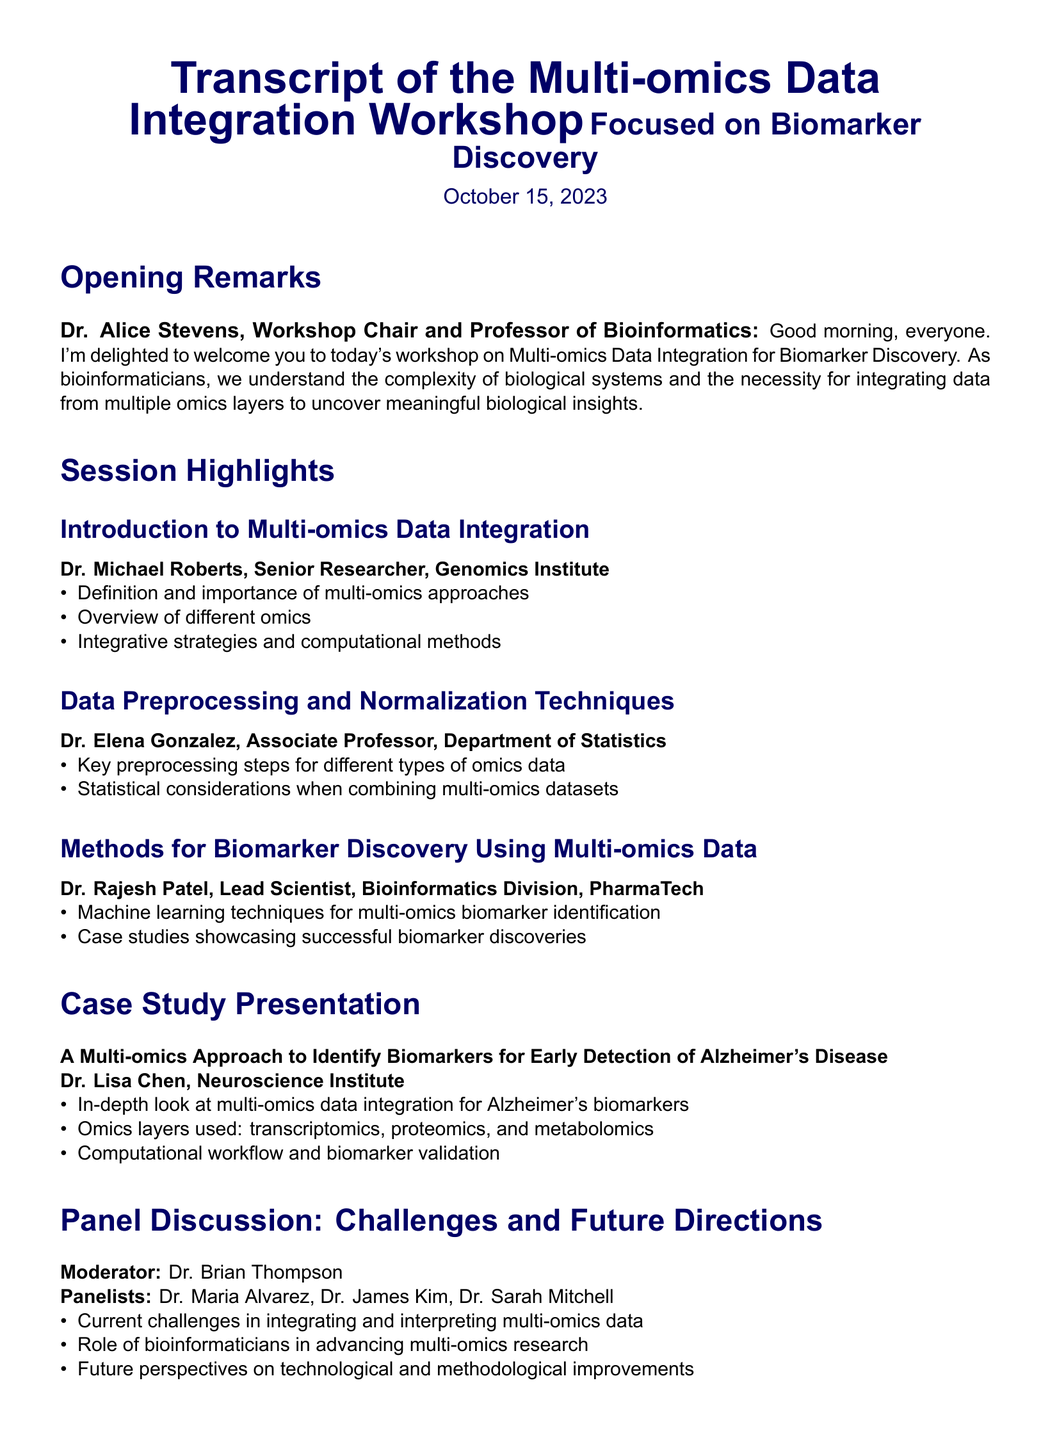What is the date of the workshop? The date of the workshop is mentioned clearly at the top of the document.
Answer: October 15, 2023 Who is the workshop chair? The workshop chair is stated in the opening remarks section.
Answer: Dr. Alice Stevens Which omics layers are used in the Alzheimer's disease case study? The omics layers are listed in the case study section under Dr. Lisa Chen's presentation.
Answer: transcriptomics, proteomics, and metabolomics What is one key topic discussed by Dr. Elena Gonzalez? Dr. Elena Gonzalez discusses key preprocessing steps, which is mentioned in her section.
Answer: Preprocessing steps What role do bioinformaticians play in multi-omics research? The panel discussion addresses the role of bioinformaticians.
Answer: Advancing research What is a method highlighted by Dr. Rajesh Patel for biomarker identification? The methods discussed by Dr. Rajesh Patel specifically mention machine learning techniques.
Answer: Machine learning techniques What kind of studies did Dr. Rajesh Patel showcase? The studies showcased by Dr. Rajesh Patel are case studies relating to biomarker discovery.
Answer: Case studies Who moderated the panel discussion? The moderator of the panel discussion is identified in the panel discussion section.
Answer: Dr. Brian Thompson What is the main theme of the workshop? The overall theme of the workshop is expressed in the title of the document.
Answer: Multi-omics Data Integration for Biomarker Discovery 